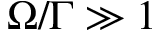Convert formula to latex. <formula><loc_0><loc_0><loc_500><loc_500>\Omega / \Gamma \gg 1</formula> 